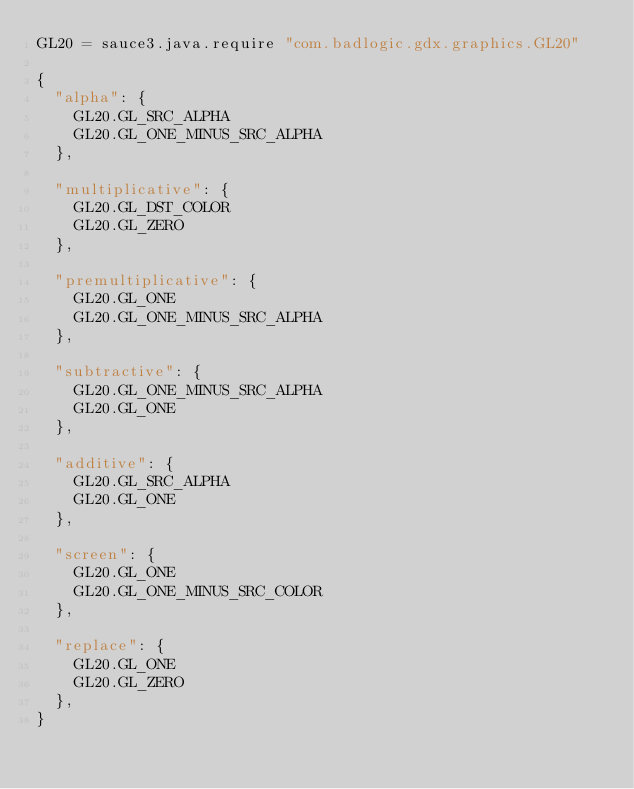<code> <loc_0><loc_0><loc_500><loc_500><_MoonScript_>GL20 = sauce3.java.require "com.badlogic.gdx.graphics.GL20"

{
  "alpha": {
    GL20.GL_SRC_ALPHA
    GL20.GL_ONE_MINUS_SRC_ALPHA
  },

  "multiplicative": {
    GL20.GL_DST_COLOR
    GL20.GL_ZERO
  },

  "premultiplicative": {
    GL20.GL_ONE
    GL20.GL_ONE_MINUS_SRC_ALPHA
  },

  "subtractive": {
    GL20.GL_ONE_MINUS_SRC_ALPHA
    GL20.GL_ONE
  },

  "additive": {
    GL20.GL_SRC_ALPHA
    GL20.GL_ONE
  },

  "screen": {
    GL20.GL_ONE
    GL20.GL_ONE_MINUS_SRC_COLOR
  },

  "replace": {
    GL20.GL_ONE
    GL20.GL_ZERO
  },
}
</code> 